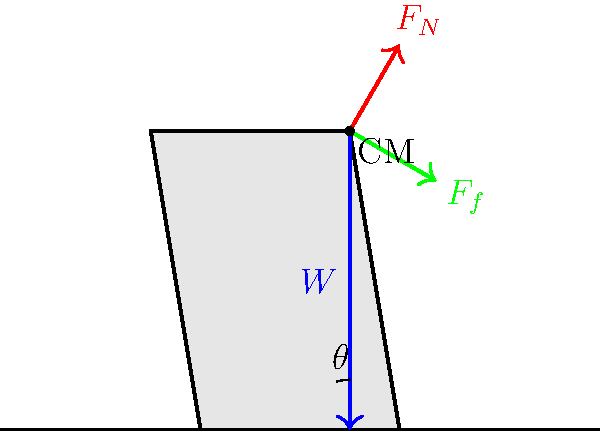An old, tilted headstone in the graveyard remains upright despite its angle. If the headstone weighs 500 N and leans at an angle of 15° from the vertical, calculate the minimum coefficient of static friction required between the headstone's base and the ground to prevent it from sliding. Let's approach this step-by-step:

1) First, we need to identify the forces acting on the headstone:
   - Weight (W) acting downward
   - Normal force (F_N) perpendicular to the ground
   - Friction force (F_f) parallel to the ground

2) The weight can be resolved into two components:
   - Parallel to the ground: $W \sin \theta$
   - Perpendicular to the ground: $W \cos \theta$

3) For equilibrium, the sum of forces in both directions must be zero:
   - Perpendicular: $F_N = W \cos \theta$
   - Parallel: $F_f = W \sin \theta$

4) The coefficient of static friction (μ) is defined as the ratio of the maximum static friction force to the normal force:
   
   $\mu = \frac{F_f}{F_N}$

5) Substituting our equilibrium equations:

   $\mu = \frac{W \sin \theta}{W \cos \theta} = \tan \theta$

6) Given:
   - $\theta = 15°$

7) Calculate:
   $\mu = \tan 15° \approx 0.2679$

Therefore, the minimum coefficient of static friction required is approximately 0.2679.
Answer: $\mu = \tan 15° \approx 0.2679$ 